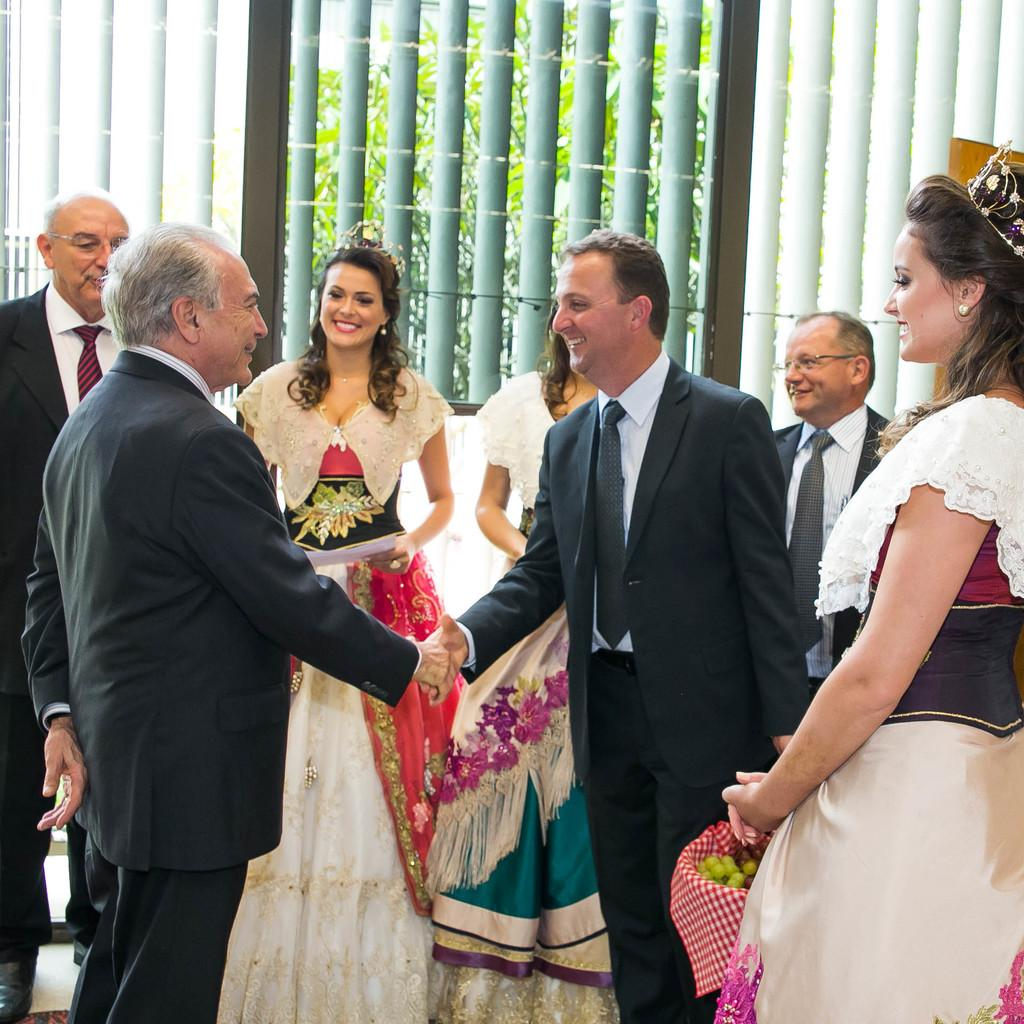Who is present in the image? There are people in the image. Can you describe the individuals in the image? There are three women in the image. What are the women wearing? The three women are wearing white dresses. What can be seen outside the window in the image? There are trees visible outside the window. What is the income of the team in the image? There is no team present in the image, and therefore no income can be associated with it. 